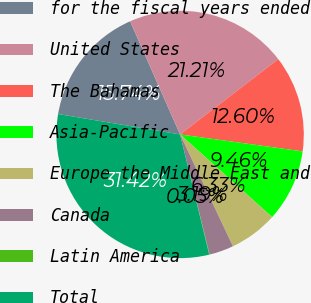<chart> <loc_0><loc_0><loc_500><loc_500><pie_chart><fcel>for the fiscal years ended<fcel>United States<fcel>The Bahamas<fcel>Asia-Pacific<fcel>Europe the Middle East and<fcel>Canada<fcel>Latin America<fcel>Total<nl><fcel>15.74%<fcel>21.21%<fcel>12.6%<fcel>9.46%<fcel>6.33%<fcel>3.19%<fcel>0.05%<fcel>31.42%<nl></chart> 